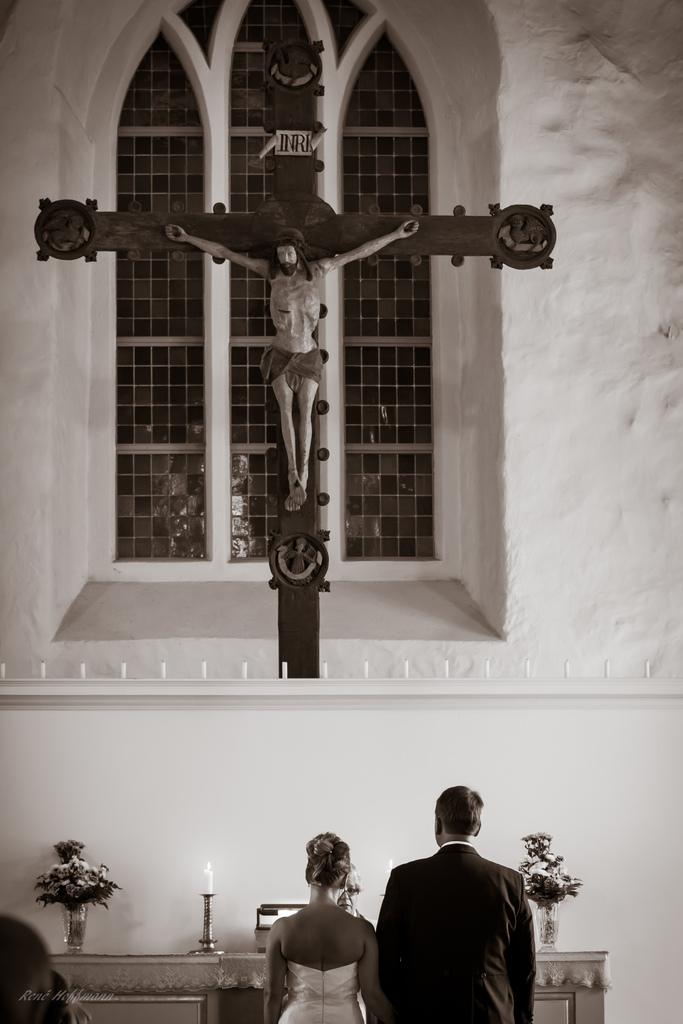How many people are in the image? There is a man and a woman standing in the image. What are the man and woman wearing? The man and woman are wearing clothes. What can be seen in the image besides the man and woman? There is a flower plant, a candle, a window, a cross symbol, and a sculpture of Jesus in the image. What type of vein is visible in the image? There is no vein visible in the image. What class are the man and woman attending in the image? The image does not depict a class or any educational setting. 